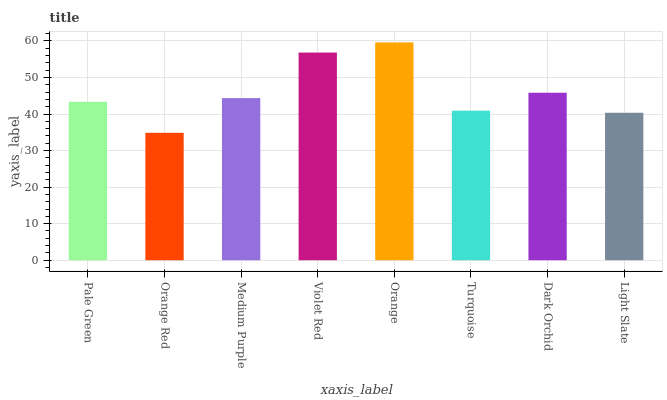Is Orange Red the minimum?
Answer yes or no. Yes. Is Orange the maximum?
Answer yes or no. Yes. Is Medium Purple the minimum?
Answer yes or no. No. Is Medium Purple the maximum?
Answer yes or no. No. Is Medium Purple greater than Orange Red?
Answer yes or no. Yes. Is Orange Red less than Medium Purple?
Answer yes or no. Yes. Is Orange Red greater than Medium Purple?
Answer yes or no. No. Is Medium Purple less than Orange Red?
Answer yes or no. No. Is Medium Purple the high median?
Answer yes or no. Yes. Is Pale Green the low median?
Answer yes or no. Yes. Is Orange Red the high median?
Answer yes or no. No. Is Orange the low median?
Answer yes or no. No. 